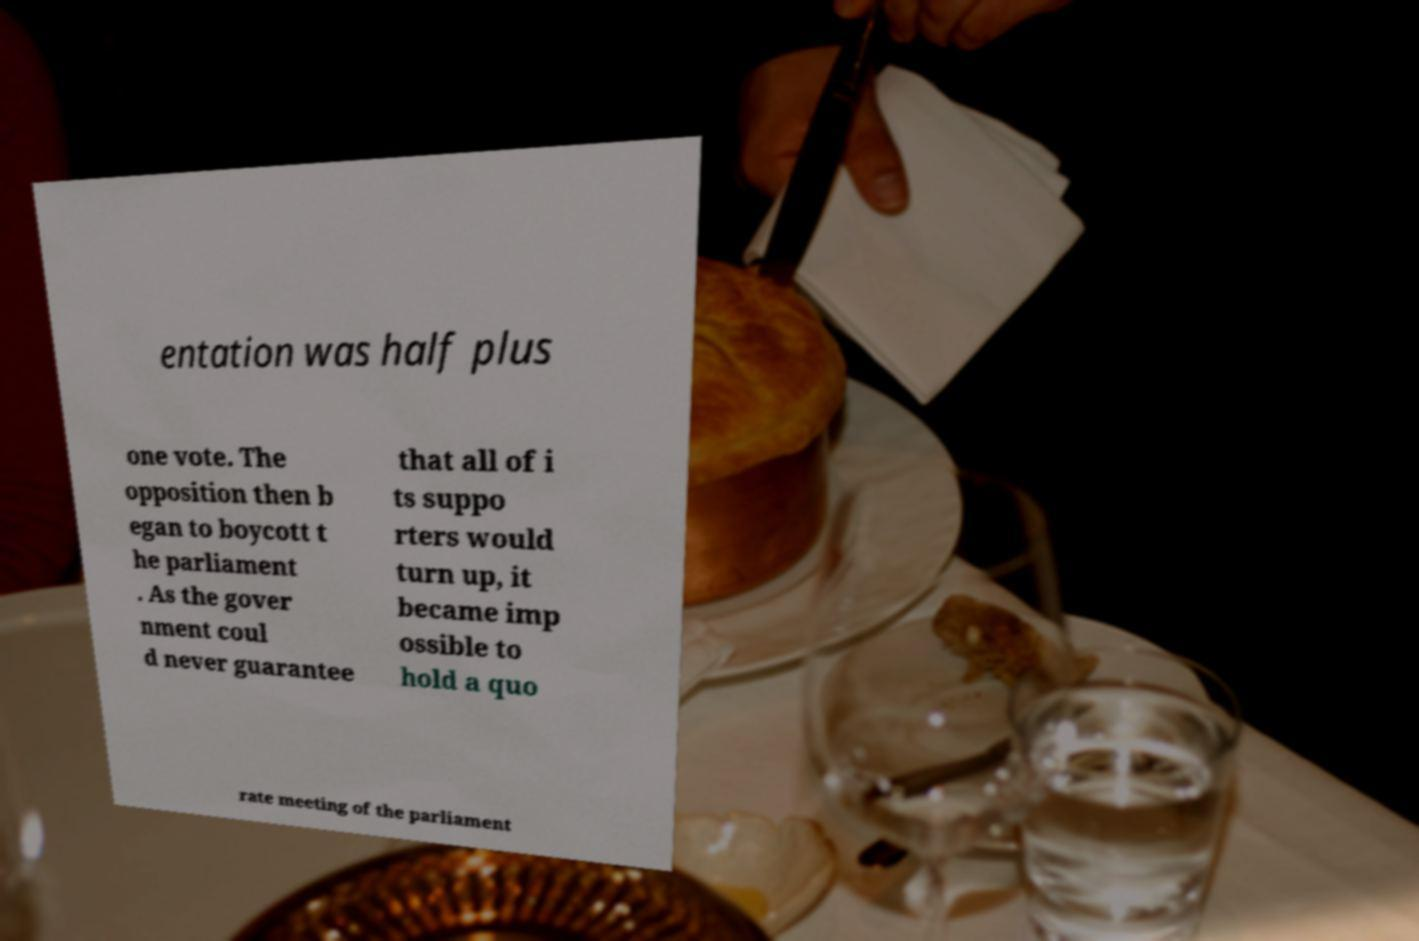Could you assist in decoding the text presented in this image and type it out clearly? entation was half plus one vote. The opposition then b egan to boycott t he parliament . As the gover nment coul d never guarantee that all of i ts suppo rters would turn up, it became imp ossible to hold a quo rate meeting of the parliament 